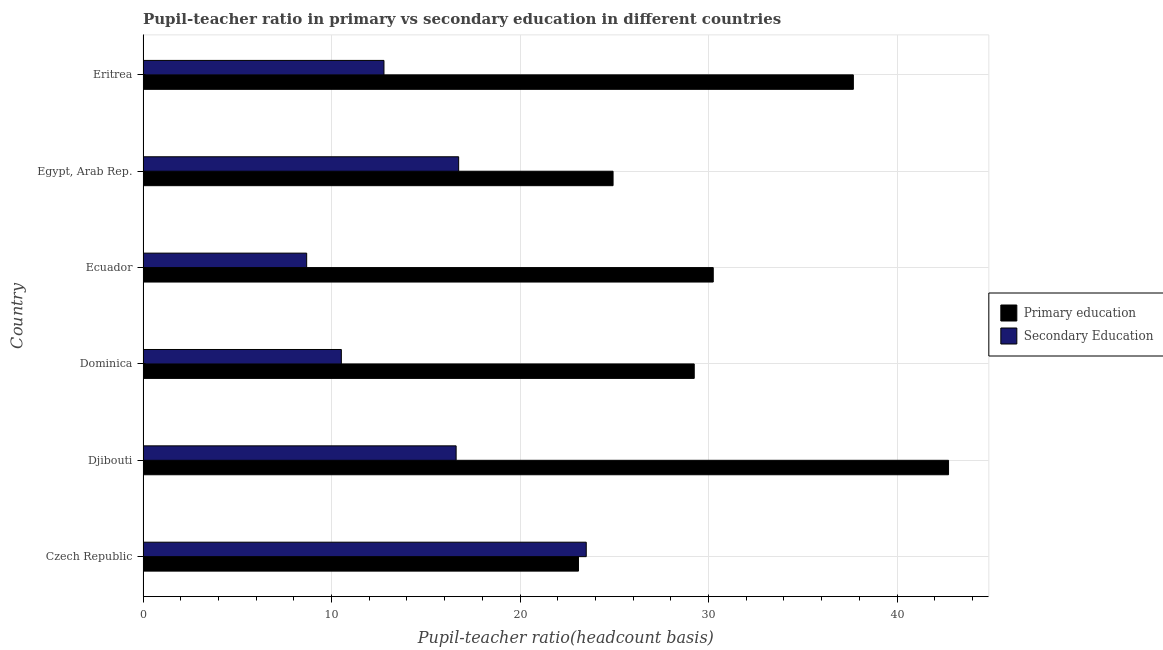Are the number of bars per tick equal to the number of legend labels?
Provide a short and direct response. Yes. Are the number of bars on each tick of the Y-axis equal?
Your answer should be very brief. Yes. How many bars are there on the 6th tick from the top?
Ensure brevity in your answer.  2. What is the label of the 1st group of bars from the top?
Ensure brevity in your answer.  Eritrea. What is the pupil teacher ratio on secondary education in Ecuador?
Offer a terse response. 8.68. Across all countries, what is the maximum pupil-teacher ratio in primary education?
Offer a very short reply. 42.73. Across all countries, what is the minimum pupil-teacher ratio in primary education?
Provide a short and direct response. 23.1. In which country was the pupil teacher ratio on secondary education maximum?
Keep it short and to the point. Czech Republic. In which country was the pupil-teacher ratio in primary education minimum?
Provide a succinct answer. Czech Republic. What is the total pupil teacher ratio on secondary education in the graph?
Offer a very short reply. 88.84. What is the difference between the pupil-teacher ratio in primary education in Ecuador and that in Eritrea?
Make the answer very short. -7.43. What is the difference between the pupil-teacher ratio in primary education in Czech Republic and the pupil teacher ratio on secondary education in Dominica?
Provide a succinct answer. 12.58. What is the average pupil teacher ratio on secondary education per country?
Give a very brief answer. 14.81. What is the difference between the pupil teacher ratio on secondary education and pupil-teacher ratio in primary education in Dominica?
Your response must be concise. -18.72. In how many countries, is the pupil-teacher ratio in primary education greater than 30 ?
Give a very brief answer. 3. What is the ratio of the pupil teacher ratio on secondary education in Czech Republic to that in Dominica?
Your response must be concise. 2.23. What is the difference between the highest and the second highest pupil teacher ratio on secondary education?
Offer a very short reply. 6.77. What is the difference between the highest and the lowest pupil-teacher ratio in primary education?
Make the answer very short. 19.63. In how many countries, is the pupil-teacher ratio in primary education greater than the average pupil-teacher ratio in primary education taken over all countries?
Keep it short and to the point. 2. Is the sum of the pupil teacher ratio on secondary education in Czech Republic and Ecuador greater than the maximum pupil-teacher ratio in primary education across all countries?
Give a very brief answer. No. What does the 2nd bar from the top in Dominica represents?
Ensure brevity in your answer.  Primary education. What does the 2nd bar from the bottom in Ecuador represents?
Provide a succinct answer. Secondary Education. Are the values on the major ticks of X-axis written in scientific E-notation?
Your answer should be compact. No. Does the graph contain any zero values?
Make the answer very short. No. Where does the legend appear in the graph?
Your answer should be compact. Center right. What is the title of the graph?
Give a very brief answer. Pupil-teacher ratio in primary vs secondary education in different countries. What is the label or title of the X-axis?
Your answer should be compact. Pupil-teacher ratio(headcount basis). What is the Pupil-teacher ratio(headcount basis) of Primary education in Czech Republic?
Your response must be concise. 23.1. What is the Pupil-teacher ratio(headcount basis) in Secondary Education in Czech Republic?
Your answer should be compact. 23.51. What is the Pupil-teacher ratio(headcount basis) in Primary education in Djibouti?
Provide a short and direct response. 42.73. What is the Pupil-teacher ratio(headcount basis) of Secondary Education in Djibouti?
Provide a short and direct response. 16.61. What is the Pupil-teacher ratio(headcount basis) in Primary education in Dominica?
Your answer should be very brief. 29.24. What is the Pupil-teacher ratio(headcount basis) of Secondary Education in Dominica?
Offer a very short reply. 10.52. What is the Pupil-teacher ratio(headcount basis) in Primary education in Ecuador?
Your answer should be very brief. 30.25. What is the Pupil-teacher ratio(headcount basis) in Secondary Education in Ecuador?
Your answer should be compact. 8.68. What is the Pupil-teacher ratio(headcount basis) of Primary education in Egypt, Arab Rep.?
Offer a very short reply. 24.93. What is the Pupil-teacher ratio(headcount basis) in Secondary Education in Egypt, Arab Rep.?
Make the answer very short. 16.74. What is the Pupil-teacher ratio(headcount basis) in Primary education in Eritrea?
Your response must be concise. 37.68. What is the Pupil-teacher ratio(headcount basis) of Secondary Education in Eritrea?
Give a very brief answer. 12.78. Across all countries, what is the maximum Pupil-teacher ratio(headcount basis) in Primary education?
Keep it short and to the point. 42.73. Across all countries, what is the maximum Pupil-teacher ratio(headcount basis) in Secondary Education?
Give a very brief answer. 23.51. Across all countries, what is the minimum Pupil-teacher ratio(headcount basis) of Primary education?
Make the answer very short. 23.1. Across all countries, what is the minimum Pupil-teacher ratio(headcount basis) in Secondary Education?
Ensure brevity in your answer.  8.68. What is the total Pupil-teacher ratio(headcount basis) in Primary education in the graph?
Your answer should be compact. 187.93. What is the total Pupil-teacher ratio(headcount basis) of Secondary Education in the graph?
Your response must be concise. 88.84. What is the difference between the Pupil-teacher ratio(headcount basis) in Primary education in Czech Republic and that in Djibouti?
Give a very brief answer. -19.63. What is the difference between the Pupil-teacher ratio(headcount basis) of Secondary Education in Czech Republic and that in Djibouti?
Offer a very short reply. 6.9. What is the difference between the Pupil-teacher ratio(headcount basis) of Primary education in Czech Republic and that in Dominica?
Offer a terse response. -6.14. What is the difference between the Pupil-teacher ratio(headcount basis) in Secondary Education in Czech Republic and that in Dominica?
Offer a terse response. 12.99. What is the difference between the Pupil-teacher ratio(headcount basis) in Primary education in Czech Republic and that in Ecuador?
Provide a succinct answer. -7.15. What is the difference between the Pupil-teacher ratio(headcount basis) of Secondary Education in Czech Republic and that in Ecuador?
Offer a very short reply. 14.83. What is the difference between the Pupil-teacher ratio(headcount basis) of Primary education in Czech Republic and that in Egypt, Arab Rep.?
Your response must be concise. -1.84. What is the difference between the Pupil-teacher ratio(headcount basis) in Secondary Education in Czech Republic and that in Egypt, Arab Rep.?
Offer a terse response. 6.77. What is the difference between the Pupil-teacher ratio(headcount basis) in Primary education in Czech Republic and that in Eritrea?
Offer a very short reply. -14.58. What is the difference between the Pupil-teacher ratio(headcount basis) of Secondary Education in Czech Republic and that in Eritrea?
Your answer should be compact. 10.73. What is the difference between the Pupil-teacher ratio(headcount basis) in Primary education in Djibouti and that in Dominica?
Make the answer very short. 13.49. What is the difference between the Pupil-teacher ratio(headcount basis) of Secondary Education in Djibouti and that in Dominica?
Provide a short and direct response. 6.09. What is the difference between the Pupil-teacher ratio(headcount basis) in Primary education in Djibouti and that in Ecuador?
Provide a short and direct response. 12.48. What is the difference between the Pupil-teacher ratio(headcount basis) in Secondary Education in Djibouti and that in Ecuador?
Keep it short and to the point. 7.93. What is the difference between the Pupil-teacher ratio(headcount basis) of Primary education in Djibouti and that in Egypt, Arab Rep.?
Offer a very short reply. 17.8. What is the difference between the Pupil-teacher ratio(headcount basis) in Secondary Education in Djibouti and that in Egypt, Arab Rep.?
Your answer should be very brief. -0.13. What is the difference between the Pupil-teacher ratio(headcount basis) in Primary education in Djibouti and that in Eritrea?
Your answer should be compact. 5.05. What is the difference between the Pupil-teacher ratio(headcount basis) of Secondary Education in Djibouti and that in Eritrea?
Give a very brief answer. 3.83. What is the difference between the Pupil-teacher ratio(headcount basis) of Primary education in Dominica and that in Ecuador?
Ensure brevity in your answer.  -1.01. What is the difference between the Pupil-teacher ratio(headcount basis) of Secondary Education in Dominica and that in Ecuador?
Your answer should be very brief. 1.84. What is the difference between the Pupil-teacher ratio(headcount basis) in Primary education in Dominica and that in Egypt, Arab Rep.?
Your answer should be compact. 4.31. What is the difference between the Pupil-teacher ratio(headcount basis) in Secondary Education in Dominica and that in Egypt, Arab Rep.?
Your response must be concise. -6.22. What is the difference between the Pupil-teacher ratio(headcount basis) in Primary education in Dominica and that in Eritrea?
Your answer should be compact. -8.44. What is the difference between the Pupil-teacher ratio(headcount basis) of Secondary Education in Dominica and that in Eritrea?
Ensure brevity in your answer.  -2.26. What is the difference between the Pupil-teacher ratio(headcount basis) of Primary education in Ecuador and that in Egypt, Arab Rep.?
Your answer should be compact. 5.32. What is the difference between the Pupil-teacher ratio(headcount basis) of Secondary Education in Ecuador and that in Egypt, Arab Rep.?
Offer a terse response. -8.06. What is the difference between the Pupil-teacher ratio(headcount basis) in Primary education in Ecuador and that in Eritrea?
Ensure brevity in your answer.  -7.43. What is the difference between the Pupil-teacher ratio(headcount basis) in Secondary Education in Ecuador and that in Eritrea?
Provide a succinct answer. -4.1. What is the difference between the Pupil-teacher ratio(headcount basis) in Primary education in Egypt, Arab Rep. and that in Eritrea?
Your answer should be compact. -12.75. What is the difference between the Pupil-teacher ratio(headcount basis) in Secondary Education in Egypt, Arab Rep. and that in Eritrea?
Your answer should be compact. 3.96. What is the difference between the Pupil-teacher ratio(headcount basis) of Primary education in Czech Republic and the Pupil-teacher ratio(headcount basis) of Secondary Education in Djibouti?
Offer a terse response. 6.49. What is the difference between the Pupil-teacher ratio(headcount basis) in Primary education in Czech Republic and the Pupil-teacher ratio(headcount basis) in Secondary Education in Dominica?
Your response must be concise. 12.58. What is the difference between the Pupil-teacher ratio(headcount basis) of Primary education in Czech Republic and the Pupil-teacher ratio(headcount basis) of Secondary Education in Ecuador?
Offer a very short reply. 14.42. What is the difference between the Pupil-teacher ratio(headcount basis) of Primary education in Czech Republic and the Pupil-teacher ratio(headcount basis) of Secondary Education in Egypt, Arab Rep.?
Your answer should be compact. 6.36. What is the difference between the Pupil-teacher ratio(headcount basis) in Primary education in Czech Republic and the Pupil-teacher ratio(headcount basis) in Secondary Education in Eritrea?
Make the answer very short. 10.32. What is the difference between the Pupil-teacher ratio(headcount basis) of Primary education in Djibouti and the Pupil-teacher ratio(headcount basis) of Secondary Education in Dominica?
Provide a succinct answer. 32.21. What is the difference between the Pupil-teacher ratio(headcount basis) in Primary education in Djibouti and the Pupil-teacher ratio(headcount basis) in Secondary Education in Ecuador?
Keep it short and to the point. 34.05. What is the difference between the Pupil-teacher ratio(headcount basis) in Primary education in Djibouti and the Pupil-teacher ratio(headcount basis) in Secondary Education in Egypt, Arab Rep.?
Offer a terse response. 25.99. What is the difference between the Pupil-teacher ratio(headcount basis) of Primary education in Djibouti and the Pupil-teacher ratio(headcount basis) of Secondary Education in Eritrea?
Provide a short and direct response. 29.95. What is the difference between the Pupil-teacher ratio(headcount basis) in Primary education in Dominica and the Pupil-teacher ratio(headcount basis) in Secondary Education in Ecuador?
Your response must be concise. 20.56. What is the difference between the Pupil-teacher ratio(headcount basis) in Primary education in Dominica and the Pupil-teacher ratio(headcount basis) in Secondary Education in Egypt, Arab Rep.?
Offer a terse response. 12.5. What is the difference between the Pupil-teacher ratio(headcount basis) in Primary education in Dominica and the Pupil-teacher ratio(headcount basis) in Secondary Education in Eritrea?
Keep it short and to the point. 16.46. What is the difference between the Pupil-teacher ratio(headcount basis) of Primary education in Ecuador and the Pupil-teacher ratio(headcount basis) of Secondary Education in Egypt, Arab Rep.?
Make the answer very short. 13.51. What is the difference between the Pupil-teacher ratio(headcount basis) in Primary education in Ecuador and the Pupil-teacher ratio(headcount basis) in Secondary Education in Eritrea?
Make the answer very short. 17.47. What is the difference between the Pupil-teacher ratio(headcount basis) in Primary education in Egypt, Arab Rep. and the Pupil-teacher ratio(headcount basis) in Secondary Education in Eritrea?
Your answer should be very brief. 12.15. What is the average Pupil-teacher ratio(headcount basis) of Primary education per country?
Your response must be concise. 31.32. What is the average Pupil-teacher ratio(headcount basis) of Secondary Education per country?
Provide a short and direct response. 14.81. What is the difference between the Pupil-teacher ratio(headcount basis) of Primary education and Pupil-teacher ratio(headcount basis) of Secondary Education in Czech Republic?
Your answer should be very brief. -0.41. What is the difference between the Pupil-teacher ratio(headcount basis) in Primary education and Pupil-teacher ratio(headcount basis) in Secondary Education in Djibouti?
Provide a short and direct response. 26.12. What is the difference between the Pupil-teacher ratio(headcount basis) of Primary education and Pupil-teacher ratio(headcount basis) of Secondary Education in Dominica?
Your answer should be very brief. 18.72. What is the difference between the Pupil-teacher ratio(headcount basis) of Primary education and Pupil-teacher ratio(headcount basis) of Secondary Education in Ecuador?
Your answer should be very brief. 21.57. What is the difference between the Pupil-teacher ratio(headcount basis) in Primary education and Pupil-teacher ratio(headcount basis) in Secondary Education in Egypt, Arab Rep.?
Ensure brevity in your answer.  8.19. What is the difference between the Pupil-teacher ratio(headcount basis) of Primary education and Pupil-teacher ratio(headcount basis) of Secondary Education in Eritrea?
Your response must be concise. 24.9. What is the ratio of the Pupil-teacher ratio(headcount basis) of Primary education in Czech Republic to that in Djibouti?
Keep it short and to the point. 0.54. What is the ratio of the Pupil-teacher ratio(headcount basis) in Secondary Education in Czech Republic to that in Djibouti?
Your response must be concise. 1.42. What is the ratio of the Pupil-teacher ratio(headcount basis) of Primary education in Czech Republic to that in Dominica?
Offer a very short reply. 0.79. What is the ratio of the Pupil-teacher ratio(headcount basis) of Secondary Education in Czech Republic to that in Dominica?
Give a very brief answer. 2.24. What is the ratio of the Pupil-teacher ratio(headcount basis) of Primary education in Czech Republic to that in Ecuador?
Make the answer very short. 0.76. What is the ratio of the Pupil-teacher ratio(headcount basis) of Secondary Education in Czech Republic to that in Ecuador?
Your response must be concise. 2.71. What is the ratio of the Pupil-teacher ratio(headcount basis) in Primary education in Czech Republic to that in Egypt, Arab Rep.?
Your answer should be compact. 0.93. What is the ratio of the Pupil-teacher ratio(headcount basis) of Secondary Education in Czech Republic to that in Egypt, Arab Rep.?
Provide a succinct answer. 1.4. What is the ratio of the Pupil-teacher ratio(headcount basis) of Primary education in Czech Republic to that in Eritrea?
Your answer should be very brief. 0.61. What is the ratio of the Pupil-teacher ratio(headcount basis) of Secondary Education in Czech Republic to that in Eritrea?
Ensure brevity in your answer.  1.84. What is the ratio of the Pupil-teacher ratio(headcount basis) of Primary education in Djibouti to that in Dominica?
Your response must be concise. 1.46. What is the ratio of the Pupil-teacher ratio(headcount basis) in Secondary Education in Djibouti to that in Dominica?
Your answer should be compact. 1.58. What is the ratio of the Pupil-teacher ratio(headcount basis) of Primary education in Djibouti to that in Ecuador?
Ensure brevity in your answer.  1.41. What is the ratio of the Pupil-teacher ratio(headcount basis) in Secondary Education in Djibouti to that in Ecuador?
Provide a short and direct response. 1.91. What is the ratio of the Pupil-teacher ratio(headcount basis) in Primary education in Djibouti to that in Egypt, Arab Rep.?
Give a very brief answer. 1.71. What is the ratio of the Pupil-teacher ratio(headcount basis) in Secondary Education in Djibouti to that in Egypt, Arab Rep.?
Give a very brief answer. 0.99. What is the ratio of the Pupil-teacher ratio(headcount basis) of Primary education in Djibouti to that in Eritrea?
Ensure brevity in your answer.  1.13. What is the ratio of the Pupil-teacher ratio(headcount basis) of Secondary Education in Djibouti to that in Eritrea?
Provide a short and direct response. 1.3. What is the ratio of the Pupil-teacher ratio(headcount basis) of Primary education in Dominica to that in Ecuador?
Provide a succinct answer. 0.97. What is the ratio of the Pupil-teacher ratio(headcount basis) of Secondary Education in Dominica to that in Ecuador?
Offer a terse response. 1.21. What is the ratio of the Pupil-teacher ratio(headcount basis) in Primary education in Dominica to that in Egypt, Arab Rep.?
Provide a succinct answer. 1.17. What is the ratio of the Pupil-teacher ratio(headcount basis) in Secondary Education in Dominica to that in Egypt, Arab Rep.?
Your answer should be very brief. 0.63. What is the ratio of the Pupil-teacher ratio(headcount basis) of Primary education in Dominica to that in Eritrea?
Your answer should be compact. 0.78. What is the ratio of the Pupil-teacher ratio(headcount basis) in Secondary Education in Dominica to that in Eritrea?
Provide a succinct answer. 0.82. What is the ratio of the Pupil-teacher ratio(headcount basis) in Primary education in Ecuador to that in Egypt, Arab Rep.?
Your response must be concise. 1.21. What is the ratio of the Pupil-teacher ratio(headcount basis) in Secondary Education in Ecuador to that in Egypt, Arab Rep.?
Give a very brief answer. 0.52. What is the ratio of the Pupil-teacher ratio(headcount basis) of Primary education in Ecuador to that in Eritrea?
Provide a succinct answer. 0.8. What is the ratio of the Pupil-teacher ratio(headcount basis) in Secondary Education in Ecuador to that in Eritrea?
Make the answer very short. 0.68. What is the ratio of the Pupil-teacher ratio(headcount basis) in Primary education in Egypt, Arab Rep. to that in Eritrea?
Your answer should be very brief. 0.66. What is the ratio of the Pupil-teacher ratio(headcount basis) in Secondary Education in Egypt, Arab Rep. to that in Eritrea?
Offer a terse response. 1.31. What is the difference between the highest and the second highest Pupil-teacher ratio(headcount basis) in Primary education?
Offer a very short reply. 5.05. What is the difference between the highest and the second highest Pupil-teacher ratio(headcount basis) in Secondary Education?
Offer a terse response. 6.77. What is the difference between the highest and the lowest Pupil-teacher ratio(headcount basis) of Primary education?
Give a very brief answer. 19.63. What is the difference between the highest and the lowest Pupil-teacher ratio(headcount basis) of Secondary Education?
Provide a succinct answer. 14.83. 